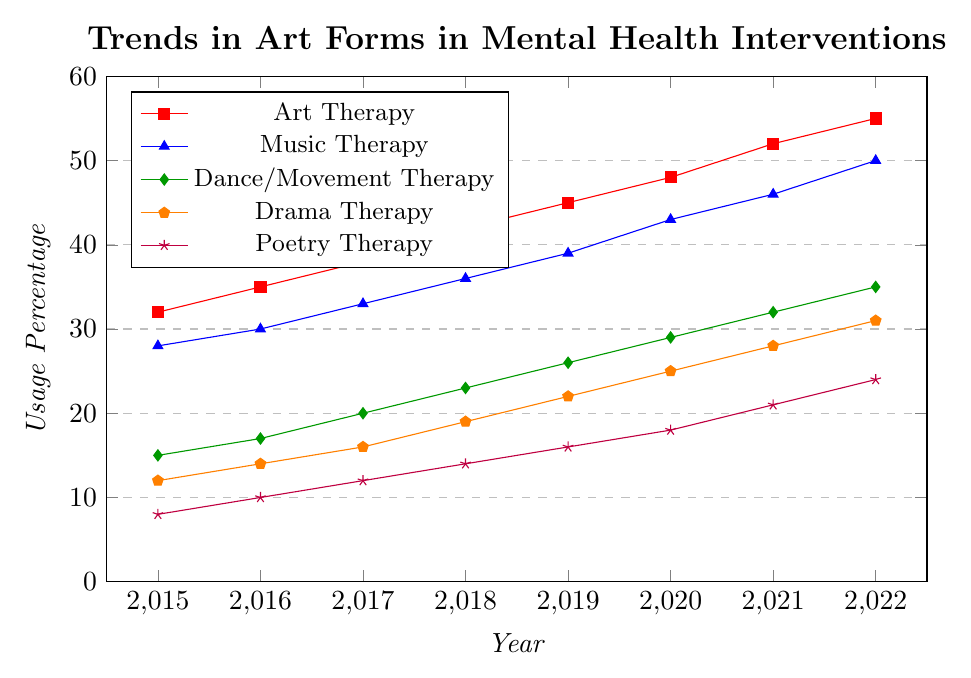What is the percentage increase in the use of Art Therapy from 2015 to 2022? The use of Art Therapy in 2015 was 32%, and it increased to 55% in 2022. To find the percentage increase: (55-32)/32 * 100 = 71.875%
Answer: 71.88% Which therapy had the highest increase in usage from 2015 to 2022? To identify the highest increase, subtract the 2015 value from the 2022 value for each therapy: Art Therapy (55-32=23), Music Therapy (50-28=22), Dance/Movement Therapy (35-15=20), Drama Therapy (31-12=19), Poetry Therapy (24-8=16). Art Therapy has the highest increase of 23%.
Answer: Art Therapy In 2018, which therapy had the lowest usage percentage? From the 2018 data points, the usage percentages are: Art Therapy (42), Music Therapy (36), Dance/Movement Therapy (23), Drama Therapy (19), Poetry Therapy (14). Poetry Therapy had the lowest usage percentage at 14% in 2018.
Answer: Poetry Therapy What was the total usage percentage of all therapies combined in 2020? Add the usage percentages of all therapies in 2020: Art Therapy (48), Music Therapy (43), Dance/Movement Therapy (29), Drama Therapy (25), Poetry Therapy (18). Total: 48+43+29+25+18 = 163.
Answer: 163 How did the usage of Drama Therapy change from 2015 to 2018? The usage of Drama Therapy in 2015 was 12% and increased to 19% in 2018. Therefore, the change is an increase of 19-12 = 7%
Answer: Increased by 7% Which therapy had the smallest average usage percentage over the years 2015 to 2022? Calculate the average for each therapy: Art Therapy (sum: 327/8 = 40.88), Music Therapy (274/8 = 34.25), Dance/Movement Therapy (192/8 = 24), Drama Therapy (167/8 = 20.88), Poetry Therapy (123/8 = 15.38). Poetry Therapy has the smallest average usage percentage.
Answer: Poetry Therapy Compare the use of Music Therapy and Poetry Therapy in 2022. Which had a higher percentage and by how much? In 2022, Music Therapy had a usage of 50%, and Poetry Therapy had 24%. The difference is 50 - 24 = 26%.
Answer: Music Therapy by 26% What is the trend of Dance/Movement Therapy usage from 2015 to 2022? The data points for Dance/Movement Therapy from 2015 to 2022 show a continuous increase each year: 15, 17, 20, 23, 26, 29, 32, 35. This indicates a rising trend.
Answer: Rising trend In which year did Art Therapy first surpass 40% usage? From the data, Art Therapy usage was: 2015 (32), 2016 (35), 2017 (38), 2018 (42). It first surpassed 40% in 2018.
Answer: 2018 